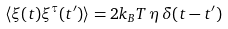Convert formula to latex. <formula><loc_0><loc_0><loc_500><loc_500>\langle \xi ( t ) \xi ^ { \tau } ( t ^ { \prime } ) \rangle = 2 k _ { B } T \, \eta \, \delta ( t - t ^ { \prime } )</formula> 